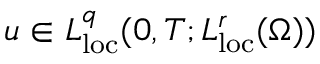<formula> <loc_0><loc_0><loc_500><loc_500>u \in L _ { l o c } ^ { q } ( 0 , T ; L _ { l o c } ^ { r } ( \Omega ) )</formula> 